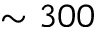Convert formula to latex. <formula><loc_0><loc_0><loc_500><loc_500>\sim 3 0 0</formula> 